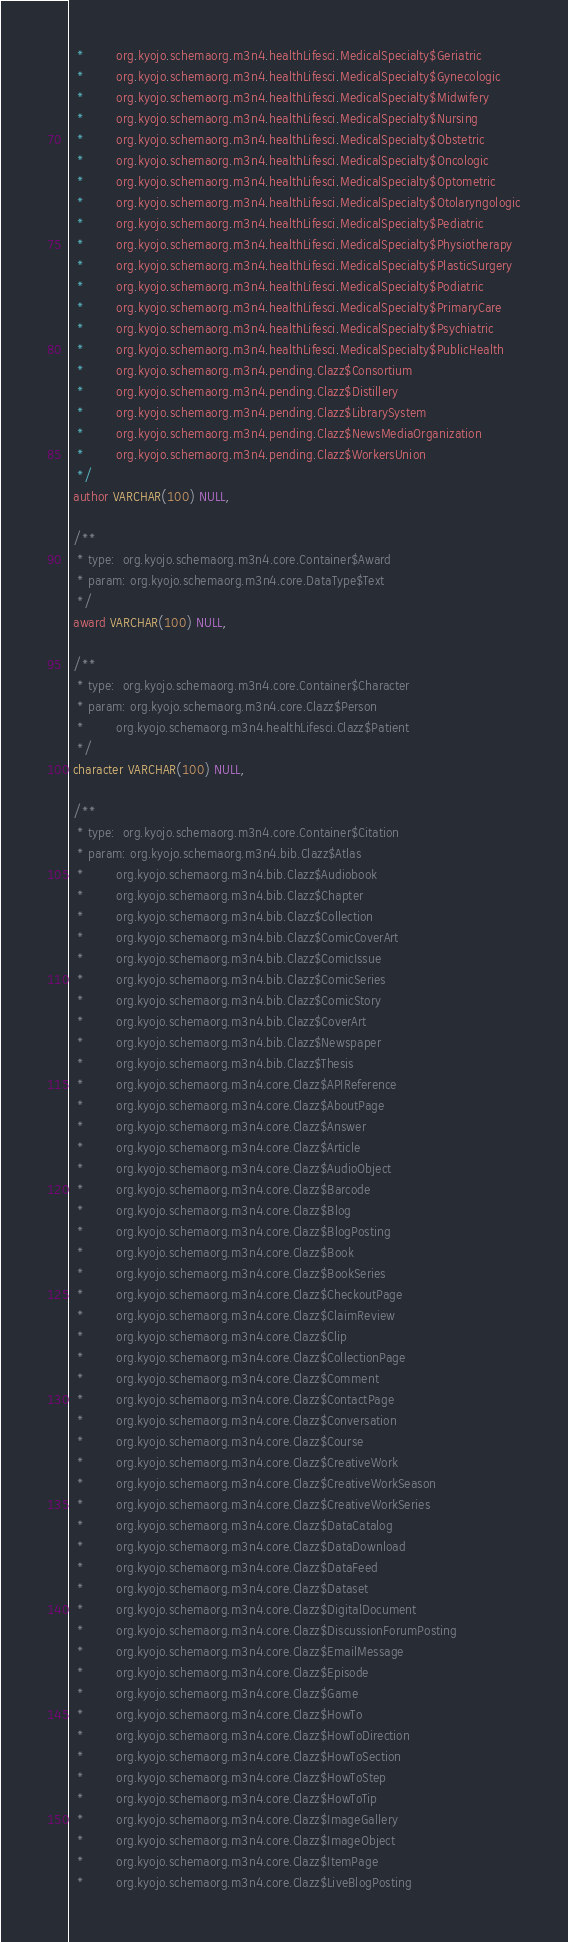Convert code to text. <code><loc_0><loc_0><loc_500><loc_500><_SQL_>  *        org.kyojo.schemaorg.m3n4.healthLifesci.MedicalSpecialty$Geriatric
  *        org.kyojo.schemaorg.m3n4.healthLifesci.MedicalSpecialty$Gynecologic
  *        org.kyojo.schemaorg.m3n4.healthLifesci.MedicalSpecialty$Midwifery
  *        org.kyojo.schemaorg.m3n4.healthLifesci.MedicalSpecialty$Nursing
  *        org.kyojo.schemaorg.m3n4.healthLifesci.MedicalSpecialty$Obstetric
  *        org.kyojo.schemaorg.m3n4.healthLifesci.MedicalSpecialty$Oncologic
  *        org.kyojo.schemaorg.m3n4.healthLifesci.MedicalSpecialty$Optometric
  *        org.kyojo.schemaorg.m3n4.healthLifesci.MedicalSpecialty$Otolaryngologic
  *        org.kyojo.schemaorg.m3n4.healthLifesci.MedicalSpecialty$Pediatric
  *        org.kyojo.schemaorg.m3n4.healthLifesci.MedicalSpecialty$Physiotherapy
  *        org.kyojo.schemaorg.m3n4.healthLifesci.MedicalSpecialty$PlasticSurgery
  *        org.kyojo.schemaorg.m3n4.healthLifesci.MedicalSpecialty$Podiatric
  *        org.kyojo.schemaorg.m3n4.healthLifesci.MedicalSpecialty$PrimaryCare
  *        org.kyojo.schemaorg.m3n4.healthLifesci.MedicalSpecialty$Psychiatric
  *        org.kyojo.schemaorg.m3n4.healthLifesci.MedicalSpecialty$PublicHealth
  *        org.kyojo.schemaorg.m3n4.pending.Clazz$Consortium
  *        org.kyojo.schemaorg.m3n4.pending.Clazz$Distillery
  *        org.kyojo.schemaorg.m3n4.pending.Clazz$LibrarySystem
  *        org.kyojo.schemaorg.m3n4.pending.Clazz$NewsMediaOrganization
  *        org.kyojo.schemaorg.m3n4.pending.Clazz$WorkersUnion
  */
 author VARCHAR(100) NULL,

 /**
  * type:  org.kyojo.schemaorg.m3n4.core.Container$Award
  * param: org.kyojo.schemaorg.m3n4.core.DataType$Text
  */
 award VARCHAR(100) NULL,

 /**
  * type:  org.kyojo.schemaorg.m3n4.core.Container$Character
  * param: org.kyojo.schemaorg.m3n4.core.Clazz$Person
  *        org.kyojo.schemaorg.m3n4.healthLifesci.Clazz$Patient
  */
 character VARCHAR(100) NULL,

 /**
  * type:  org.kyojo.schemaorg.m3n4.core.Container$Citation
  * param: org.kyojo.schemaorg.m3n4.bib.Clazz$Atlas
  *        org.kyojo.schemaorg.m3n4.bib.Clazz$Audiobook
  *        org.kyojo.schemaorg.m3n4.bib.Clazz$Chapter
  *        org.kyojo.schemaorg.m3n4.bib.Clazz$Collection
  *        org.kyojo.schemaorg.m3n4.bib.Clazz$ComicCoverArt
  *        org.kyojo.schemaorg.m3n4.bib.Clazz$ComicIssue
  *        org.kyojo.schemaorg.m3n4.bib.Clazz$ComicSeries
  *        org.kyojo.schemaorg.m3n4.bib.Clazz$ComicStory
  *        org.kyojo.schemaorg.m3n4.bib.Clazz$CoverArt
  *        org.kyojo.schemaorg.m3n4.bib.Clazz$Newspaper
  *        org.kyojo.schemaorg.m3n4.bib.Clazz$Thesis
  *        org.kyojo.schemaorg.m3n4.core.Clazz$APIReference
  *        org.kyojo.schemaorg.m3n4.core.Clazz$AboutPage
  *        org.kyojo.schemaorg.m3n4.core.Clazz$Answer
  *        org.kyojo.schemaorg.m3n4.core.Clazz$Article
  *        org.kyojo.schemaorg.m3n4.core.Clazz$AudioObject
  *        org.kyojo.schemaorg.m3n4.core.Clazz$Barcode
  *        org.kyojo.schemaorg.m3n4.core.Clazz$Blog
  *        org.kyojo.schemaorg.m3n4.core.Clazz$BlogPosting
  *        org.kyojo.schemaorg.m3n4.core.Clazz$Book
  *        org.kyojo.schemaorg.m3n4.core.Clazz$BookSeries
  *        org.kyojo.schemaorg.m3n4.core.Clazz$CheckoutPage
  *        org.kyojo.schemaorg.m3n4.core.Clazz$ClaimReview
  *        org.kyojo.schemaorg.m3n4.core.Clazz$Clip
  *        org.kyojo.schemaorg.m3n4.core.Clazz$CollectionPage
  *        org.kyojo.schemaorg.m3n4.core.Clazz$Comment
  *        org.kyojo.schemaorg.m3n4.core.Clazz$ContactPage
  *        org.kyojo.schemaorg.m3n4.core.Clazz$Conversation
  *        org.kyojo.schemaorg.m3n4.core.Clazz$Course
  *        org.kyojo.schemaorg.m3n4.core.Clazz$CreativeWork
  *        org.kyojo.schemaorg.m3n4.core.Clazz$CreativeWorkSeason
  *        org.kyojo.schemaorg.m3n4.core.Clazz$CreativeWorkSeries
  *        org.kyojo.schemaorg.m3n4.core.Clazz$DataCatalog
  *        org.kyojo.schemaorg.m3n4.core.Clazz$DataDownload
  *        org.kyojo.schemaorg.m3n4.core.Clazz$DataFeed
  *        org.kyojo.schemaorg.m3n4.core.Clazz$Dataset
  *        org.kyojo.schemaorg.m3n4.core.Clazz$DigitalDocument
  *        org.kyojo.schemaorg.m3n4.core.Clazz$DiscussionForumPosting
  *        org.kyojo.schemaorg.m3n4.core.Clazz$EmailMessage
  *        org.kyojo.schemaorg.m3n4.core.Clazz$Episode
  *        org.kyojo.schemaorg.m3n4.core.Clazz$Game
  *        org.kyojo.schemaorg.m3n4.core.Clazz$HowTo
  *        org.kyojo.schemaorg.m3n4.core.Clazz$HowToDirection
  *        org.kyojo.schemaorg.m3n4.core.Clazz$HowToSection
  *        org.kyojo.schemaorg.m3n4.core.Clazz$HowToStep
  *        org.kyojo.schemaorg.m3n4.core.Clazz$HowToTip
  *        org.kyojo.schemaorg.m3n4.core.Clazz$ImageGallery
  *        org.kyojo.schemaorg.m3n4.core.Clazz$ImageObject
  *        org.kyojo.schemaorg.m3n4.core.Clazz$ItemPage
  *        org.kyojo.schemaorg.m3n4.core.Clazz$LiveBlogPosting</code> 